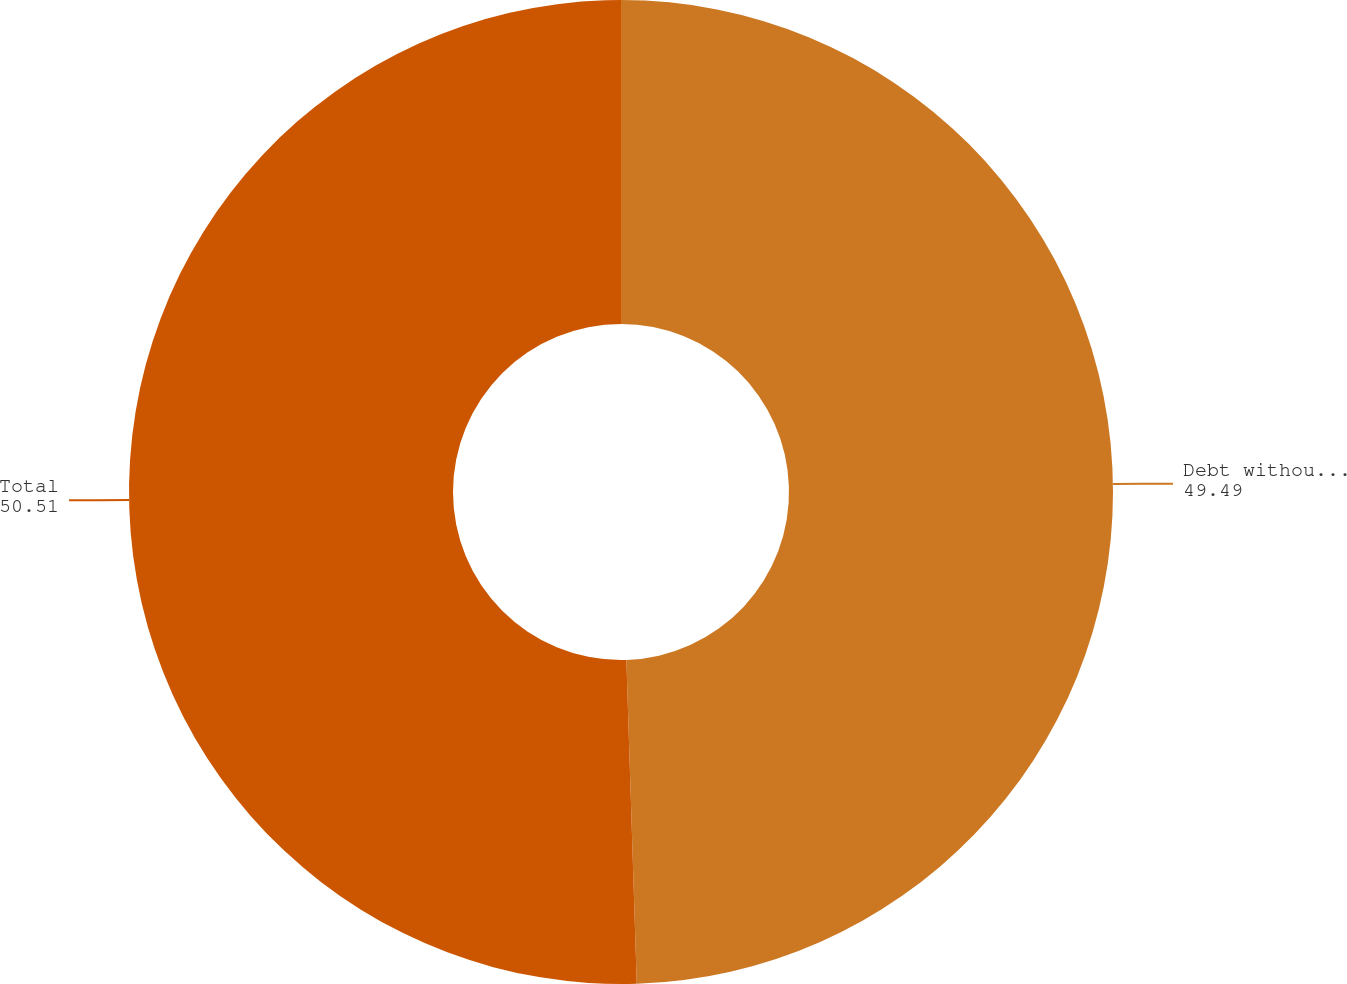<chart> <loc_0><loc_0><loc_500><loc_500><pie_chart><fcel>Debt without recourse to<fcel>Total<nl><fcel>49.49%<fcel>50.51%<nl></chart> 